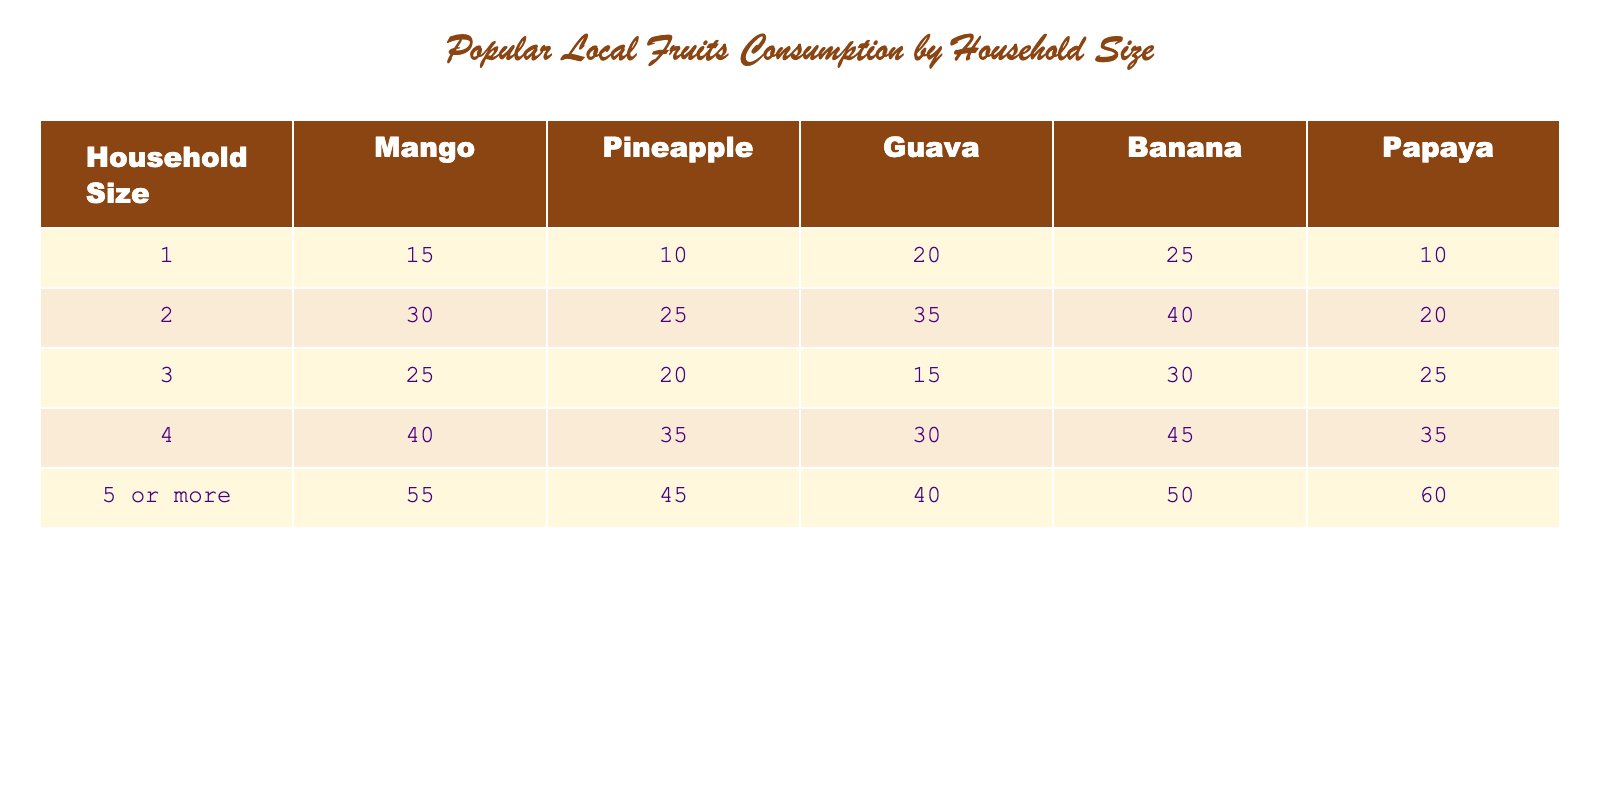What household size consumes the most Mango? By looking at the column for Mango, the household size of "5 or more" has the highest consumption rate at 55.
Answer: 5 or more What is the total consumption of Pineapple for households of size 1 and 2 combined? For household size 1, the consumption is 10, and for size 2, it is 25. Summing these gives 10 + 25 = 35.
Answer: 35 Is the consumption of Banana higher for households of size 4 than for size 3? For household size 4, the consumption of Banana is 45, while for size 3 it is 30. Since 45 is greater than 30, the answer is yes.
Answer: Yes What is the average consumption of Guava across all household sizes? The total consumption of Guava is 20 + 35 + 15 + 30 + 40 = 140. There are 5 household sizes, so the average is 140 / 5 = 28.
Answer: 28 Which fruit has the highest total consumption across all household sizes? We sum the consumption for each fruit: Mango (15 + 30 + 25 + 40 + 55 = 165), Pineapple (10 + 25 + 20 + 35 + 45 = 135), Guava (20 + 35 + 15 + 30 + 40 = 140), Banana (25 + 40 + 30 + 45 + 50 = 220), and Papaya (10 + 20 + 25 + 35 + 60 = 150). The highest total is for Banana at 220.
Answer: Banana Is it true that the consumption of Papaya increases with the size of the household? Checking the Papaya column, the values are 10, 20, 25, 35, and 60 for household sizes 1 through 5 or more, respectively. This shows a consistent increase, hence the answer is yes.
Answer: Yes What is the difference in Guava consumption between households of size 2 and size 4? For size 2, the consumption of Guava is 35, and for size 4, it is 30. The difference is 35 - 30 = 5.
Answer: 5 What fruit has the lowest consumption rate among households of size 3? In household size 3, the consumption of each fruit is: Mango (25), Pineapple (20), Guava (15), Banana (30), Papaya (25). The lowest consumption is for Guava with 15.
Answer: Guava 